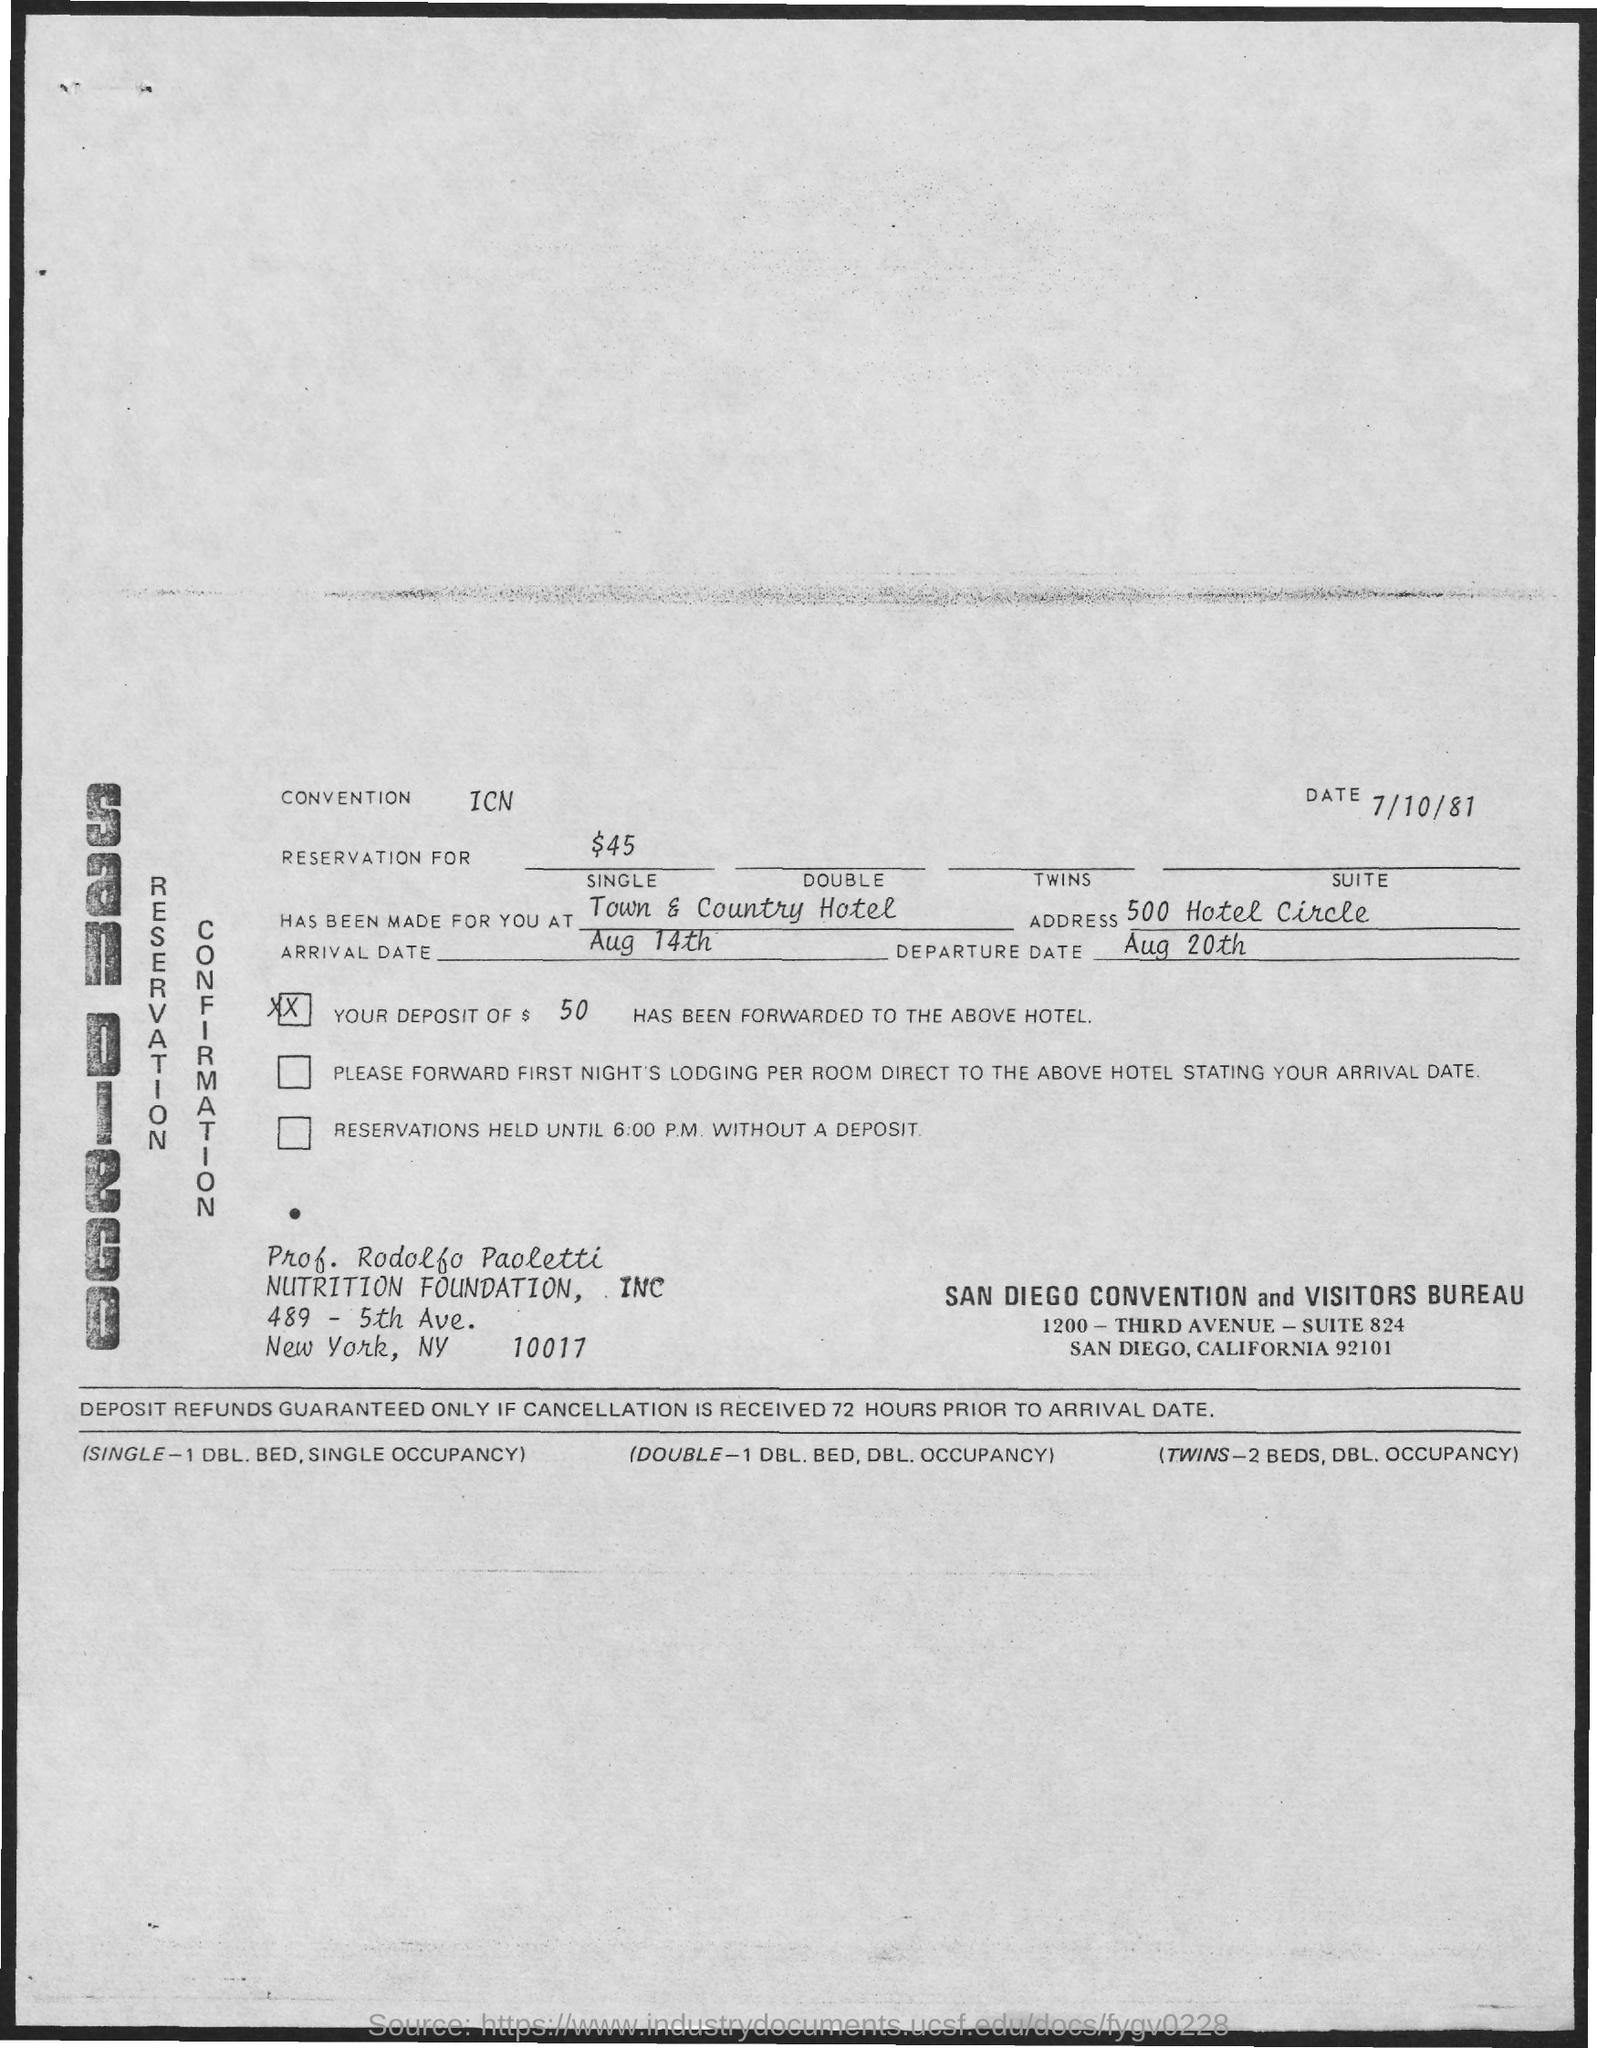Outline some significant characteristics in this image. The arrival date is August 14th. The Convention Field contains the value ICN. The departure date is August 20th. The date mentioned at the top of the document is 7/10/81. 